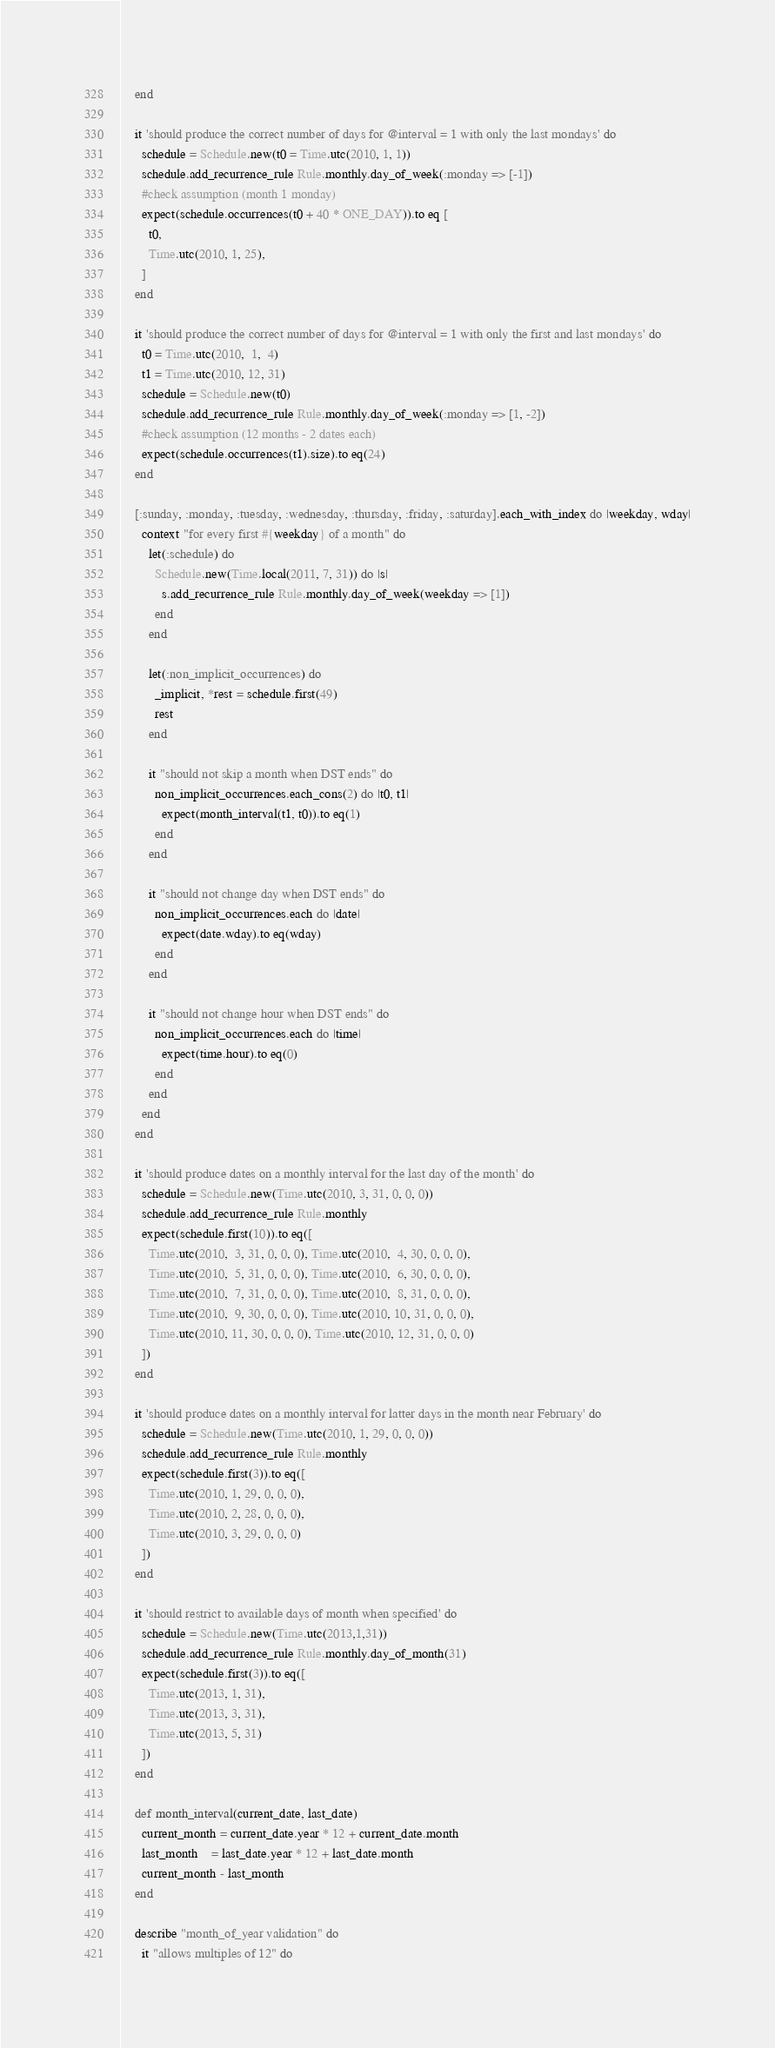<code> <loc_0><loc_0><loc_500><loc_500><_Ruby_>    end

    it 'should produce the correct number of days for @interval = 1 with only the last mondays' do
      schedule = Schedule.new(t0 = Time.utc(2010, 1, 1))
      schedule.add_recurrence_rule Rule.monthly.day_of_week(:monday => [-1])
      #check assumption (month 1 monday)
      expect(schedule.occurrences(t0 + 40 * ONE_DAY)).to eq [
        t0,
        Time.utc(2010, 1, 25),
      ]
    end

    it 'should produce the correct number of days for @interval = 1 with only the first and last mondays' do
      t0 = Time.utc(2010,  1,  4)
      t1 = Time.utc(2010, 12, 31)
      schedule = Schedule.new(t0)
      schedule.add_recurrence_rule Rule.monthly.day_of_week(:monday => [1, -2])
      #check assumption (12 months - 2 dates each)
      expect(schedule.occurrences(t1).size).to eq(24)
    end

    [:sunday, :monday, :tuesday, :wednesday, :thursday, :friday, :saturday].each_with_index do |weekday, wday|
      context "for every first #{weekday} of a month" do
        let(:schedule) do
          Schedule.new(Time.local(2011, 7, 31)) do |s|
            s.add_recurrence_rule Rule.monthly.day_of_week(weekday => [1])
          end
        end

        let(:non_implicit_occurrences) do
          _implicit, *rest = schedule.first(49)
          rest
        end

        it "should not skip a month when DST ends" do
          non_implicit_occurrences.each_cons(2) do |t0, t1|
            expect(month_interval(t1, t0)).to eq(1)
          end
        end

        it "should not change day when DST ends" do
          non_implicit_occurrences.each do |date|
            expect(date.wday).to eq(wday)
          end
        end

        it "should not change hour when DST ends" do
          non_implicit_occurrences.each do |time|
            expect(time.hour).to eq(0)
          end
        end
      end
    end

    it 'should produce dates on a monthly interval for the last day of the month' do
      schedule = Schedule.new(Time.utc(2010, 3, 31, 0, 0, 0))
      schedule.add_recurrence_rule Rule.monthly
      expect(schedule.first(10)).to eq([
        Time.utc(2010,  3, 31, 0, 0, 0), Time.utc(2010,  4, 30, 0, 0, 0),
        Time.utc(2010,  5, 31, 0, 0, 0), Time.utc(2010,  6, 30, 0, 0, 0),
        Time.utc(2010,  7, 31, 0, 0, 0), Time.utc(2010,  8, 31, 0, 0, 0),
        Time.utc(2010,  9, 30, 0, 0, 0), Time.utc(2010, 10, 31, 0, 0, 0),
        Time.utc(2010, 11, 30, 0, 0, 0), Time.utc(2010, 12, 31, 0, 0, 0)
      ])
    end

    it 'should produce dates on a monthly interval for latter days in the month near February' do
      schedule = Schedule.new(Time.utc(2010, 1, 29, 0, 0, 0))
      schedule.add_recurrence_rule Rule.monthly
      expect(schedule.first(3)).to eq([
        Time.utc(2010, 1, 29, 0, 0, 0),
        Time.utc(2010, 2, 28, 0, 0, 0),
        Time.utc(2010, 3, 29, 0, 0, 0)
      ])
    end

    it 'should restrict to available days of month when specified' do
      schedule = Schedule.new(Time.utc(2013,1,31))
      schedule.add_recurrence_rule Rule.monthly.day_of_month(31)
      expect(schedule.first(3)).to eq([
        Time.utc(2013, 1, 31),
        Time.utc(2013, 3, 31),
        Time.utc(2013, 5, 31)
      ])
    end

    def month_interval(current_date, last_date)
      current_month = current_date.year * 12 + current_date.month
      last_month    = last_date.year * 12 + last_date.month
      current_month - last_month
    end

    describe "month_of_year validation" do
      it "allows multiples of 12" do</code> 